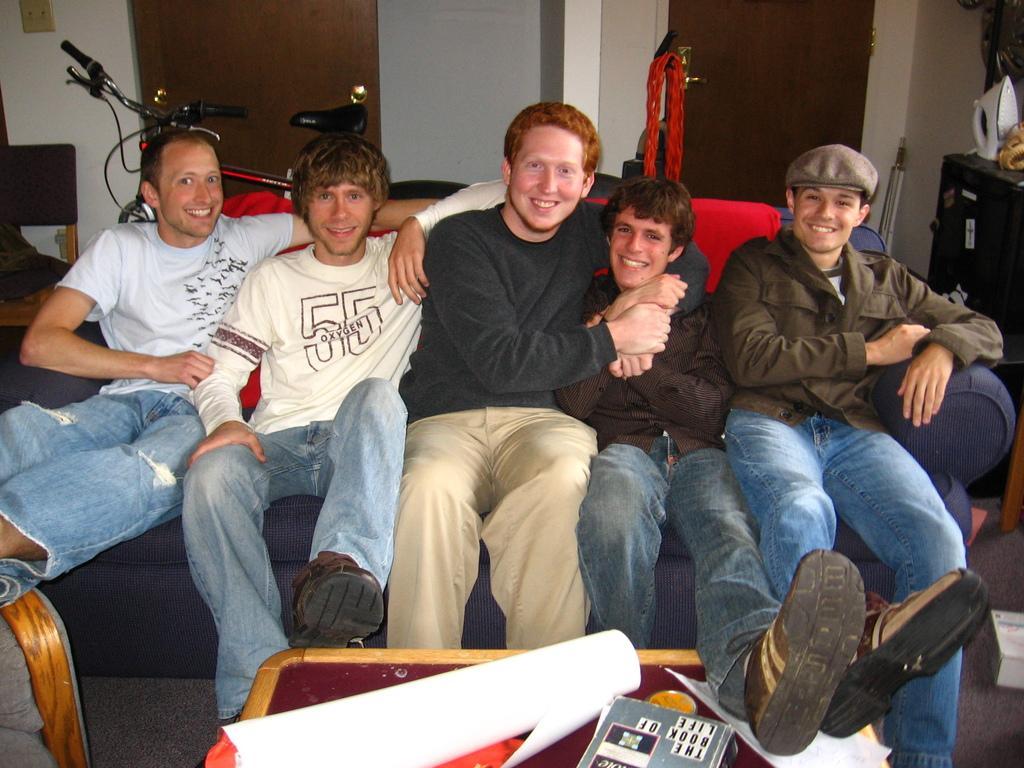How would you summarize this image in a sentence or two? In this picture we can see the group of friends sitting couch smiling and giving a pose into the camera. In front on the table we can see paper and a book. Behind you can see a bicycle, wooden door and grey color wall. 